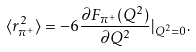Convert formula to latex. <formula><loc_0><loc_0><loc_500><loc_500>\langle r _ { \pi ^ { + } } ^ { 2 } \rangle = - 6 \frac { \partial F _ { \pi ^ { + } } ( Q ^ { 2 } ) } { \partial Q ^ { 2 } } | _ { Q ^ { 2 } = 0 } .</formula> 